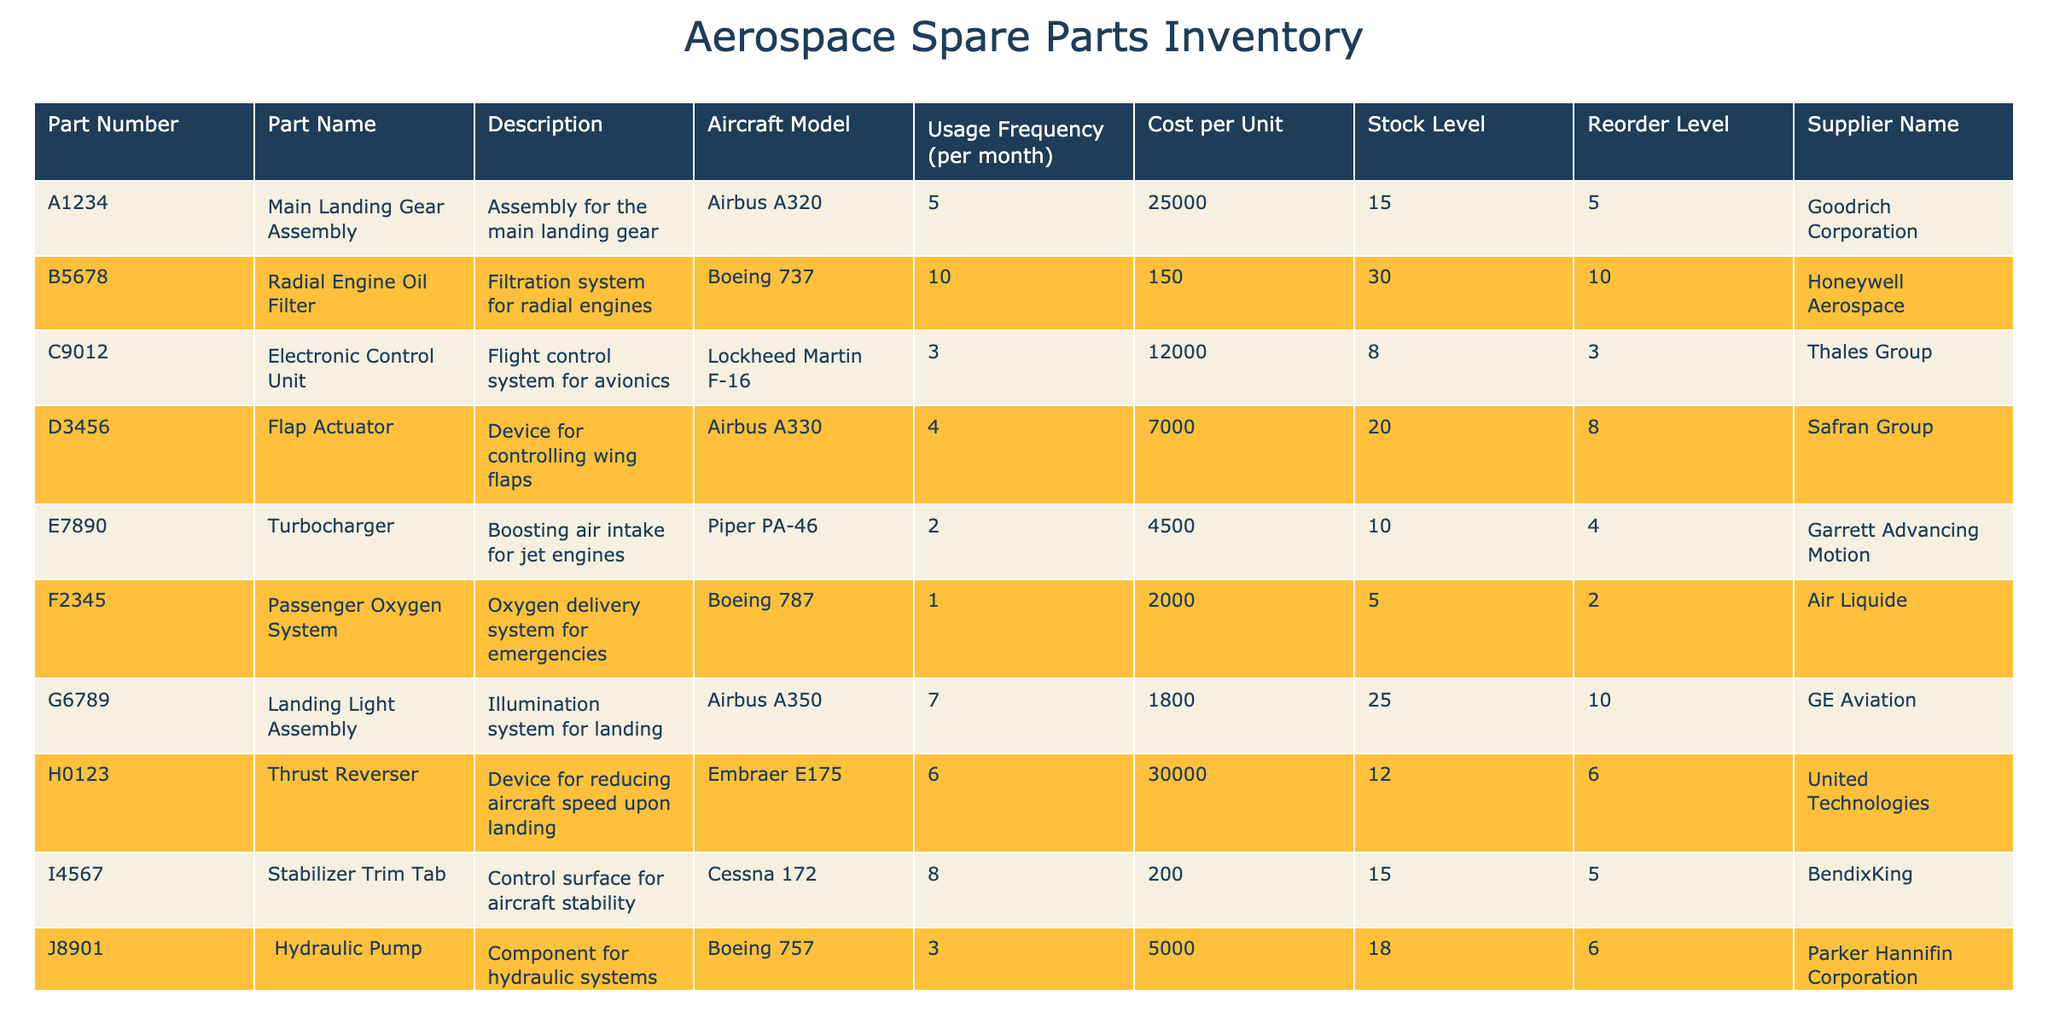What is the cost per unit of the Electronic Control Unit? The cost per unit of the Electronic Control Unit is located in the Cost per Unit column corresponding to the part number C9012. Looking at that row, the value is 12000.
Answer: 12000 Which part has the highest usage frequency per month? To find the part with the highest usage frequency, we look at the Usage Frequency (per month) column and identify the maximum value. The Radial Engine Oil Filter has the highest frequency at 10 per month.
Answer: Radial Engine Oil Filter What is the total stock level for all parts? To calculate the total stock level, we need to sum the Stock Level column. Adding up all stock levels: 15 + 30 + 8 + 20 + 10 + 5 + 25 + 12 + 15 + 18 =  153.
Answer: 153 Is the Flap Actuator below its reorder level? We can check the Flap Actuator's stock level and reorder level by referring to its row. The stock level is 20 and the reorder level is 8. Since 20 is greater than 8, it is not below the reorder level.
Answer: No How many parts are supplied by Goodrich Corporation? By examining the Supplier Name column, we can count the occurrences of Goodrich Corporation. It's found in the row for the Main Landing Gear Assembly, so there is 1 part supplied by them.
Answer: 1 What is the average cost per unit of all parts? To find the average cost per unit, we add all cost values: 25000 + 150 + 12000 + 7000 + 4500 + 2000 + 1800 + 30000 + 200 + 5000 =  17,652. Then divide this sum by the number of parts (10). Thus, the average cost per unit is 17,652 / 10 = 1765.2.
Answer: 1765.2 Are any parts supplied by Honeywell Aerospace? By scanning the Supplier Name column, we find that the Radial Engine Oil Filter is supplied by Honeywell Aerospace. Therefore, the answer to this question is yes.
Answer: Yes Which part has the lowest usage frequency and what is it? We need to inspect the Usage Frequency (per month) column and find the lowest value. The Passenger Oxygen System has the lowest frequency at 1 usage per month, making it the answer.
Answer: Passenger Oxygen System 